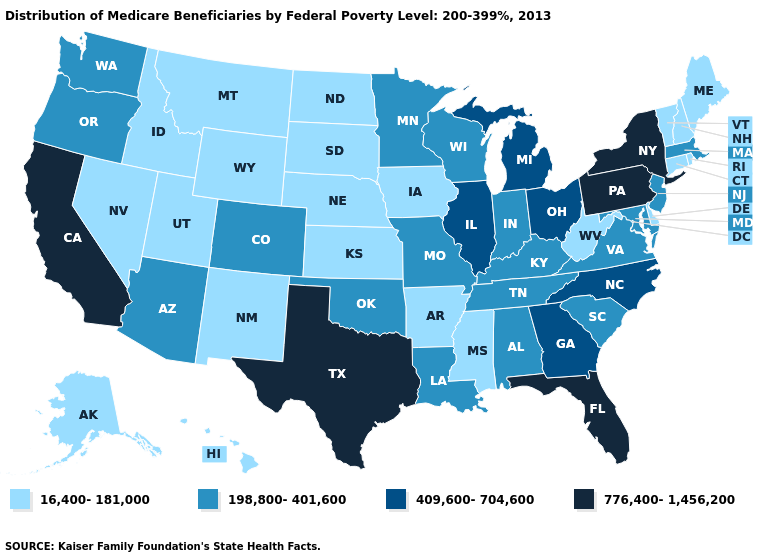Name the states that have a value in the range 776,400-1,456,200?
Write a very short answer. California, Florida, New York, Pennsylvania, Texas. Does Kentucky have a higher value than Georgia?
Short answer required. No. What is the value of Ohio?
Answer briefly. 409,600-704,600. What is the highest value in states that border Missouri?
Short answer required. 409,600-704,600. How many symbols are there in the legend?
Answer briefly. 4. Name the states that have a value in the range 409,600-704,600?
Keep it brief. Georgia, Illinois, Michigan, North Carolina, Ohio. Among the states that border Utah , does Colorado have the highest value?
Short answer required. Yes. Does Maine have the lowest value in the Northeast?
Be succinct. Yes. What is the value of Idaho?
Write a very short answer. 16,400-181,000. Among the states that border West Virginia , does Pennsylvania have the highest value?
Short answer required. Yes. Does Nevada have the highest value in the USA?
Quick response, please. No. Name the states that have a value in the range 198,800-401,600?
Write a very short answer. Alabama, Arizona, Colorado, Indiana, Kentucky, Louisiana, Maryland, Massachusetts, Minnesota, Missouri, New Jersey, Oklahoma, Oregon, South Carolina, Tennessee, Virginia, Washington, Wisconsin. What is the lowest value in states that border Illinois?
Quick response, please. 16,400-181,000. What is the value of Oregon?
Write a very short answer. 198,800-401,600. Does North Carolina have the lowest value in the USA?
Concise answer only. No. 